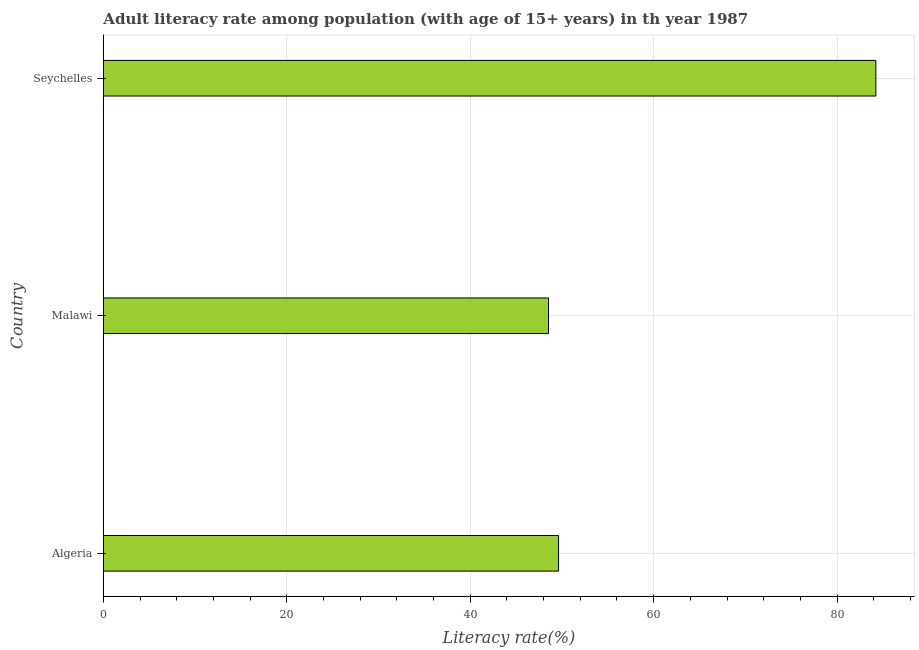Does the graph contain any zero values?
Offer a very short reply. No. What is the title of the graph?
Keep it short and to the point. Adult literacy rate among population (with age of 15+ years) in th year 1987. What is the label or title of the X-axis?
Your answer should be compact. Literacy rate(%). What is the adult literacy rate in Malawi?
Provide a short and direct response. 48.54. Across all countries, what is the maximum adult literacy rate?
Your response must be concise. 84.23. Across all countries, what is the minimum adult literacy rate?
Ensure brevity in your answer.  48.54. In which country was the adult literacy rate maximum?
Offer a very short reply. Seychelles. In which country was the adult literacy rate minimum?
Keep it short and to the point. Malawi. What is the sum of the adult literacy rate?
Make the answer very short. 182.4. What is the difference between the adult literacy rate in Algeria and Seychelles?
Your response must be concise. -34.6. What is the average adult literacy rate per country?
Provide a short and direct response. 60.8. What is the median adult literacy rate?
Make the answer very short. 49.63. What is the ratio of the adult literacy rate in Algeria to that in Seychelles?
Your response must be concise. 0.59. What is the difference between the highest and the second highest adult literacy rate?
Offer a very short reply. 34.6. Is the sum of the adult literacy rate in Malawi and Seychelles greater than the maximum adult literacy rate across all countries?
Give a very brief answer. Yes. What is the difference between the highest and the lowest adult literacy rate?
Your answer should be compact. 35.69. In how many countries, is the adult literacy rate greater than the average adult literacy rate taken over all countries?
Your response must be concise. 1. How many bars are there?
Provide a succinct answer. 3. How many countries are there in the graph?
Your answer should be very brief. 3. Are the values on the major ticks of X-axis written in scientific E-notation?
Provide a succinct answer. No. What is the Literacy rate(%) in Algeria?
Make the answer very short. 49.63. What is the Literacy rate(%) in Malawi?
Offer a very short reply. 48.54. What is the Literacy rate(%) of Seychelles?
Offer a very short reply. 84.23. What is the difference between the Literacy rate(%) in Algeria and Malawi?
Your answer should be very brief. 1.09. What is the difference between the Literacy rate(%) in Algeria and Seychelles?
Offer a terse response. -34.6. What is the difference between the Literacy rate(%) in Malawi and Seychelles?
Offer a terse response. -35.69. What is the ratio of the Literacy rate(%) in Algeria to that in Seychelles?
Offer a terse response. 0.59. What is the ratio of the Literacy rate(%) in Malawi to that in Seychelles?
Make the answer very short. 0.58. 